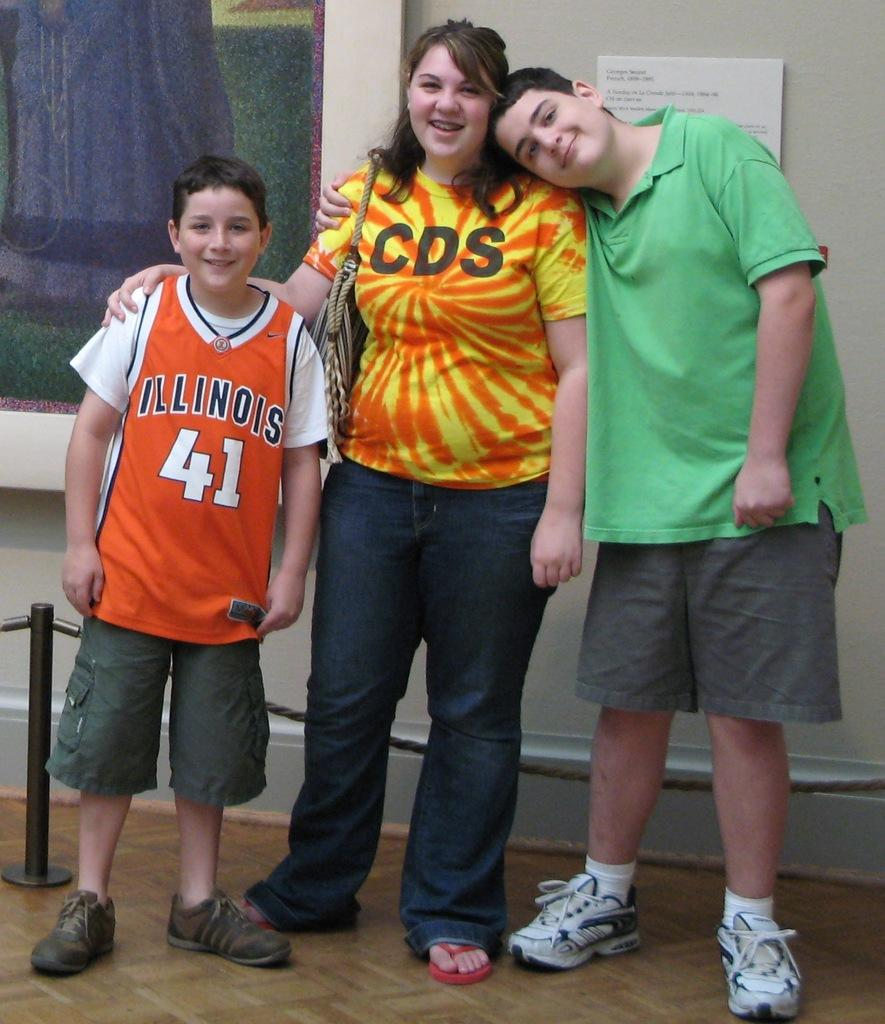<image>
Give a short and clear explanation of the subsequent image. A group of people are standing for a photo and one of their shirts says Illinois. 